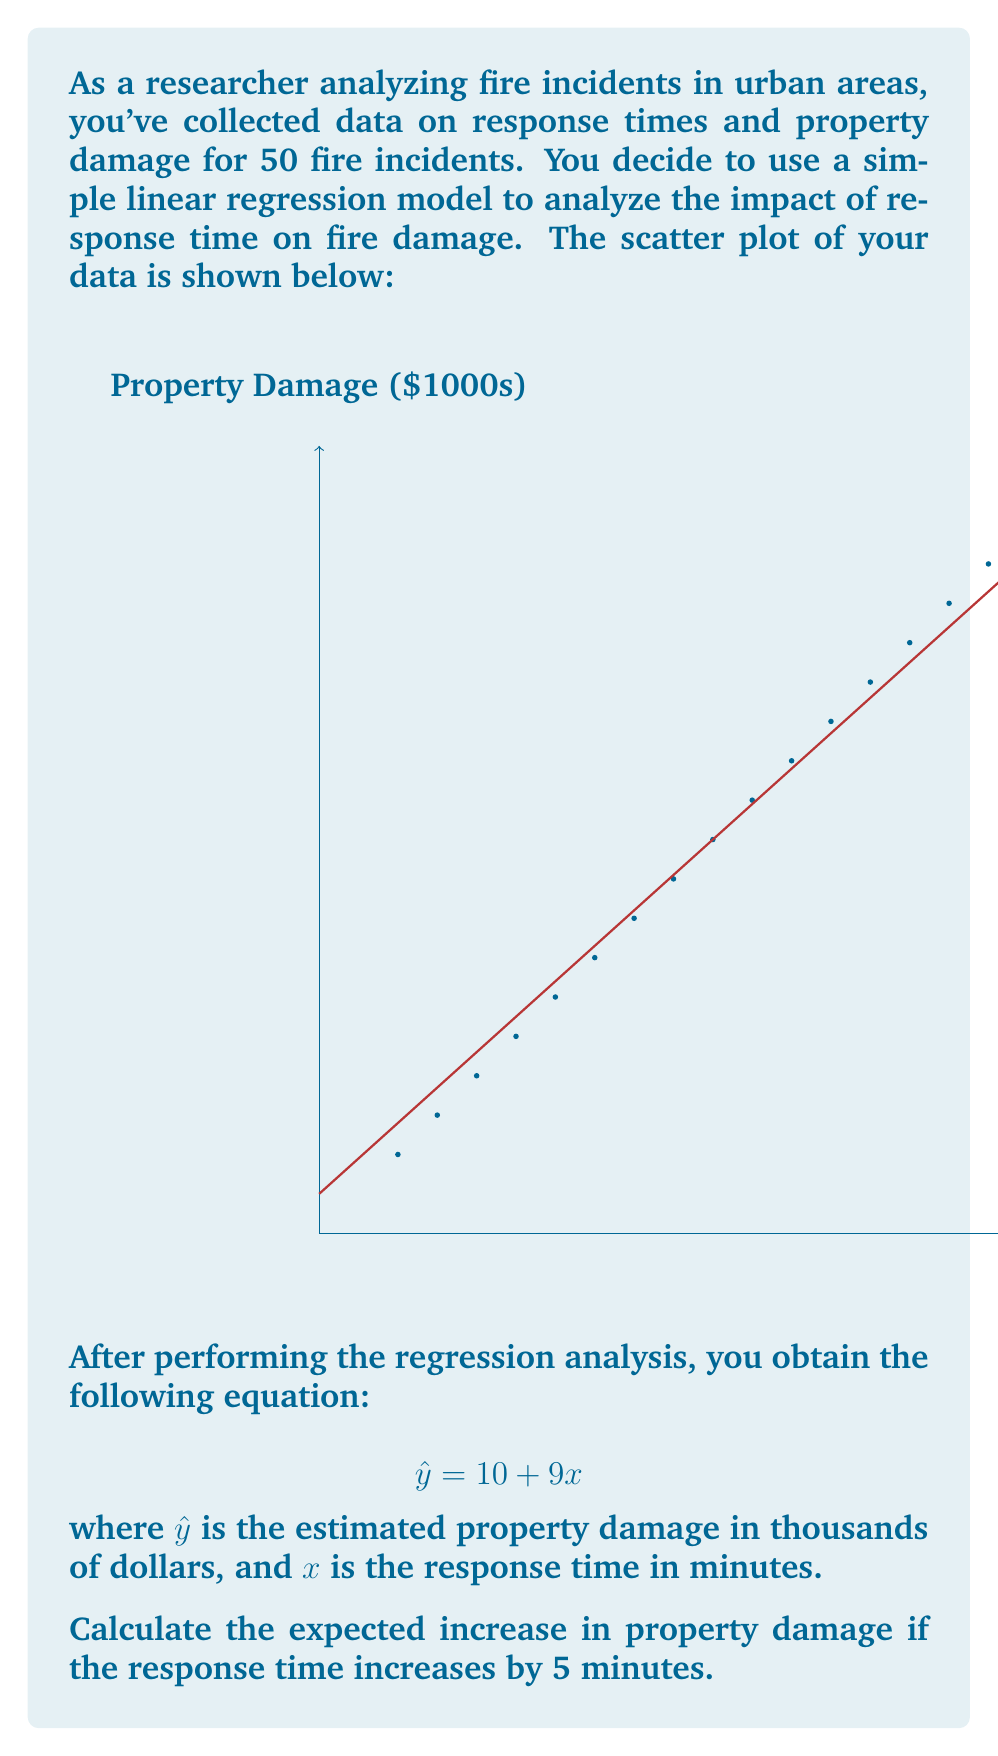Could you help me with this problem? To solve this problem, we'll follow these steps:

1) We're given the linear regression equation:
   $$ \hat{y} = 10 + 9x $$
   where $\hat{y}$ is the estimated property damage (in $1000s) and $x$ is the response time (in minutes).

2) The slope of this line, 9, represents the change in $\hat{y}$ for a one-unit change in $x$. In other words, for every 1-minute increase in response time, the property damage is expected to increase by $9,000.

3) We want to know the increase in property damage for a 5-minute increase in response time.

4) To calculate this, we multiply the slope by 5:
   $$ 9 \times 5 = 45 $$

5) This means that for a 5-minute increase in response time, we expect the property damage to increase by 45 thousand dollars, or $45,000.
Answer: $45,000 